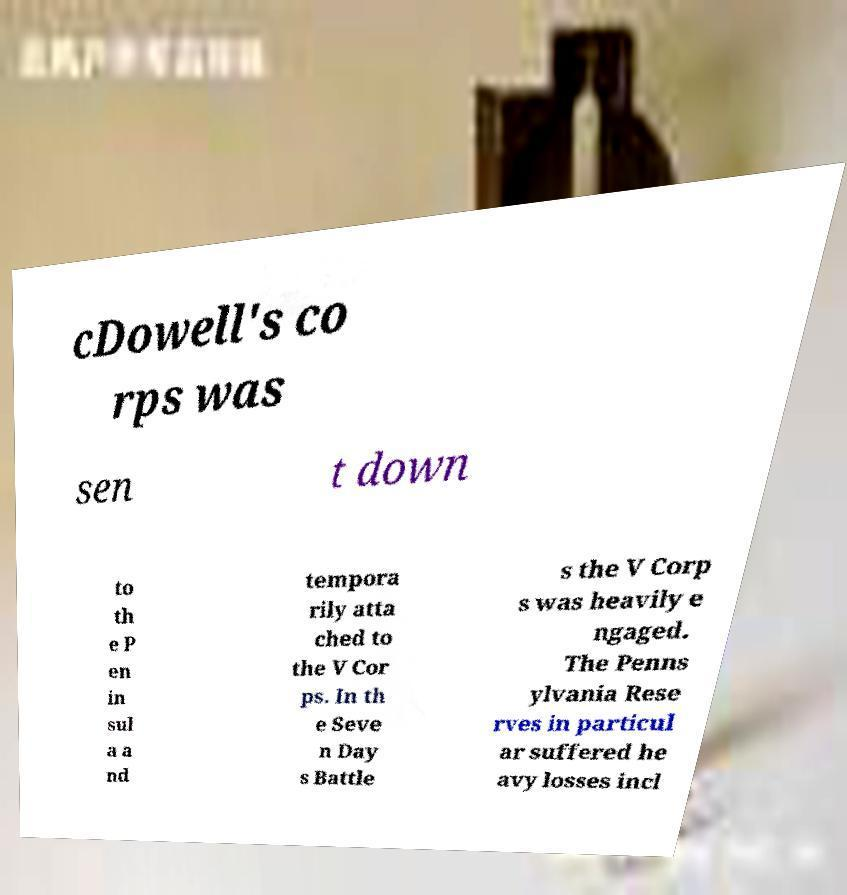For documentation purposes, I need the text within this image transcribed. Could you provide that? cDowell's co rps was sen t down to th e P en in sul a a nd tempora rily atta ched to the V Cor ps. In th e Seve n Day s Battle s the V Corp s was heavily e ngaged. The Penns ylvania Rese rves in particul ar suffered he avy losses incl 